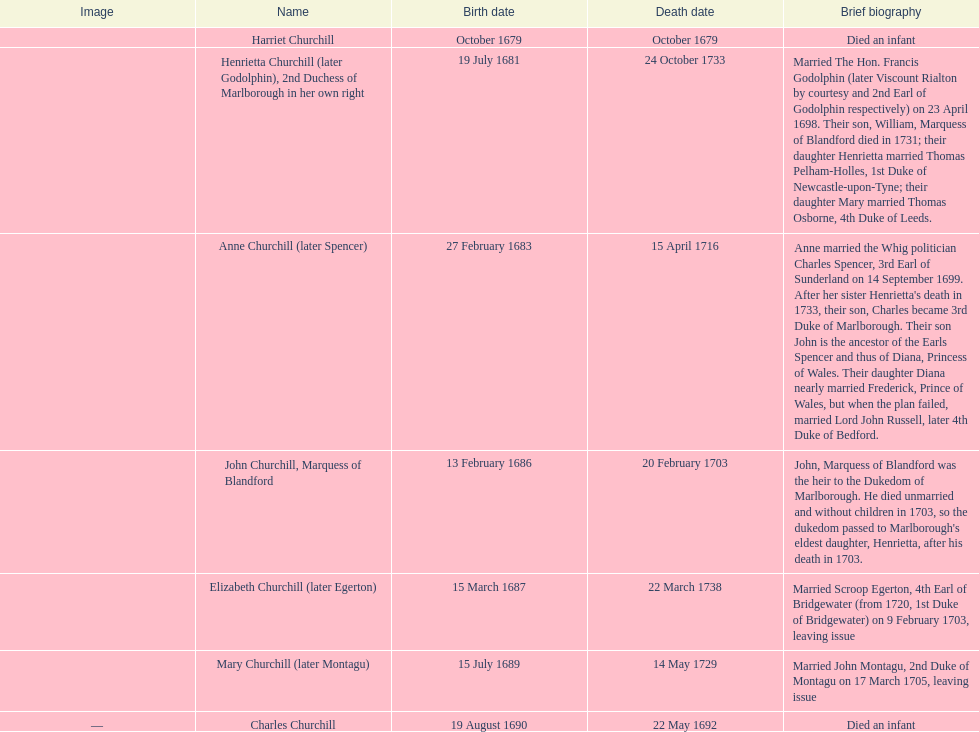Which kid was the initial one to pass away? Harriet Churchill. 